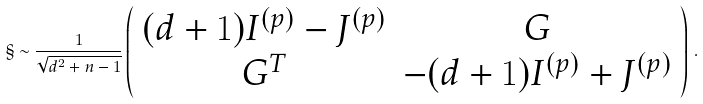Convert formula to latex. <formula><loc_0><loc_0><loc_500><loc_500>\S \sim \frac { 1 } { \sqrt { d ^ { 2 } + n - 1 } } \left ( \begin{array} { c c } ( d + 1 ) I ^ { ( p ) } - J ^ { ( p ) } & G \\ G ^ { T } & - ( d + 1 ) I ^ { ( p ) } + J ^ { ( p ) } \end{array} \right ) \, .</formula> 